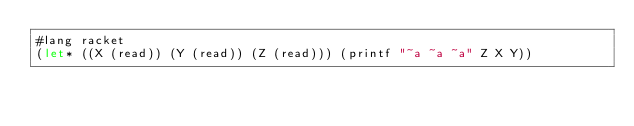<code> <loc_0><loc_0><loc_500><loc_500><_Racket_>#lang racket
(let* ((X (read)) (Y (read)) (Z (read))) (printf "~a ~a ~a" Z X Y))</code> 